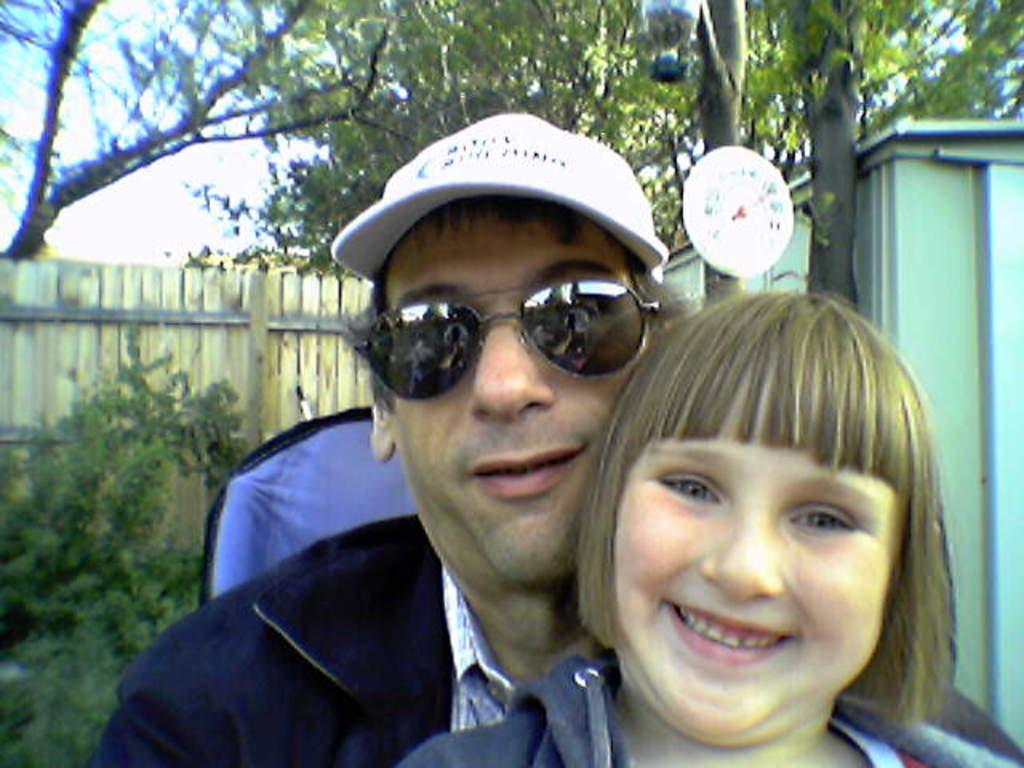What can be seen in the center of the image? There are people in the center of the image. Can you describe the appearance of any of the people? One of the people is wearing glasses, and another is wearing a cap. What is visible in the background of the image? There are trees, a fence, a board, and a shed in the background of the image. What type of mouth apparatus is being used by the person in the image? There is no mouth apparatus present in the image. What level of difficulty is the board game in the background of the image? There is no board game visible in the image. 